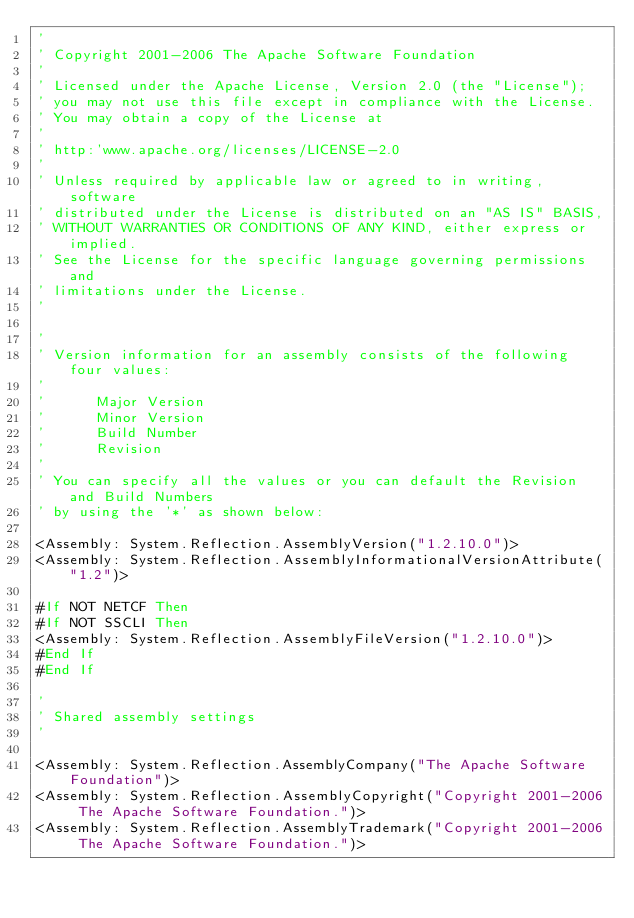Convert code to text. <code><loc_0><loc_0><loc_500><loc_500><_VisualBasic_>'
' Copyright 2001-2006 The Apache Software Foundation
'
' Licensed under the Apache License, Version 2.0 (the "License");
' you may not use this file except in compliance with the License.
' You may obtain a copy of the License at
'
' http:'www.apache.org/licenses/LICENSE-2.0
'
' Unless required by applicable law or agreed to in writing, software
' distributed under the License is distributed on an "AS IS" BASIS,
' WITHOUT WARRANTIES OR CONDITIONS OF ANY KIND, either express or implied.
' See the License for the specific language governing permissions and
' limitations under the License.
'

'
' Version information for an assembly consists of the following four values:
'
'      Major Version
'      Minor Version 
'      Build Number
'      Revision
'
' You can specify all the values or you can default the Revision and Build Numbers 
' by using the '*' as shown below:

<Assembly: System.Reflection.AssemblyVersion("1.2.10.0")>
<Assembly: System.Reflection.AssemblyInformationalVersionAttribute("1.2")>

#If NOT NETCF Then
#If NOT SSCLI Then
<Assembly: System.Reflection.AssemblyFileVersion("1.2.10.0")>
#End If
#End If

'
' Shared assembly settings
'

<Assembly: System.Reflection.AssemblyCompany("The Apache Software Foundation")>
<Assembly: System.Reflection.AssemblyCopyright("Copyright 2001-2006 The Apache Software Foundation.")>
<Assembly: System.Reflection.AssemblyTrademark("Copyright 2001-2006 The Apache Software Foundation.")>
</code> 